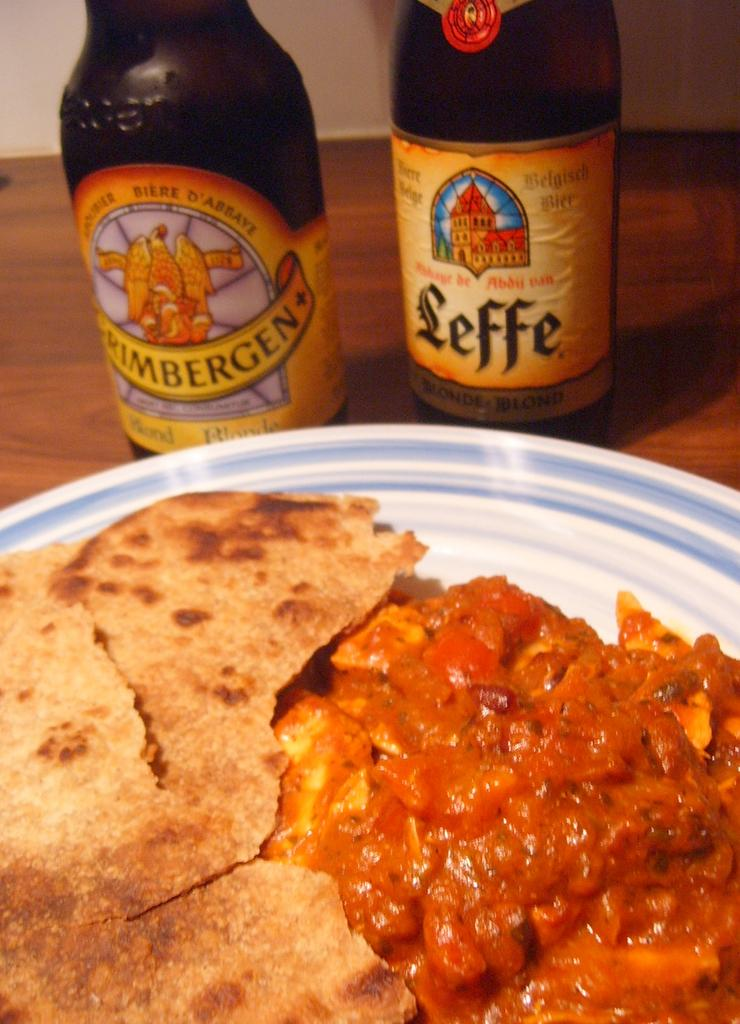<image>
Summarize the visual content of the image. Plate of food by a bottle that says LEFFE. 